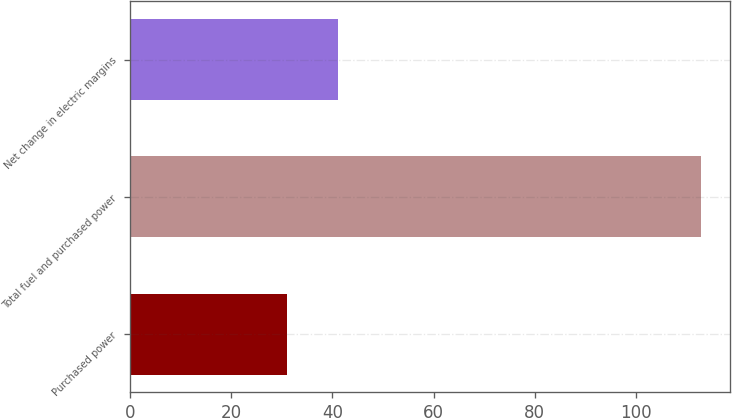<chart> <loc_0><loc_0><loc_500><loc_500><bar_chart><fcel>Purchased power<fcel>Total fuel and purchased power<fcel>Net change in electric margins<nl><fcel>31<fcel>113<fcel>41<nl></chart> 